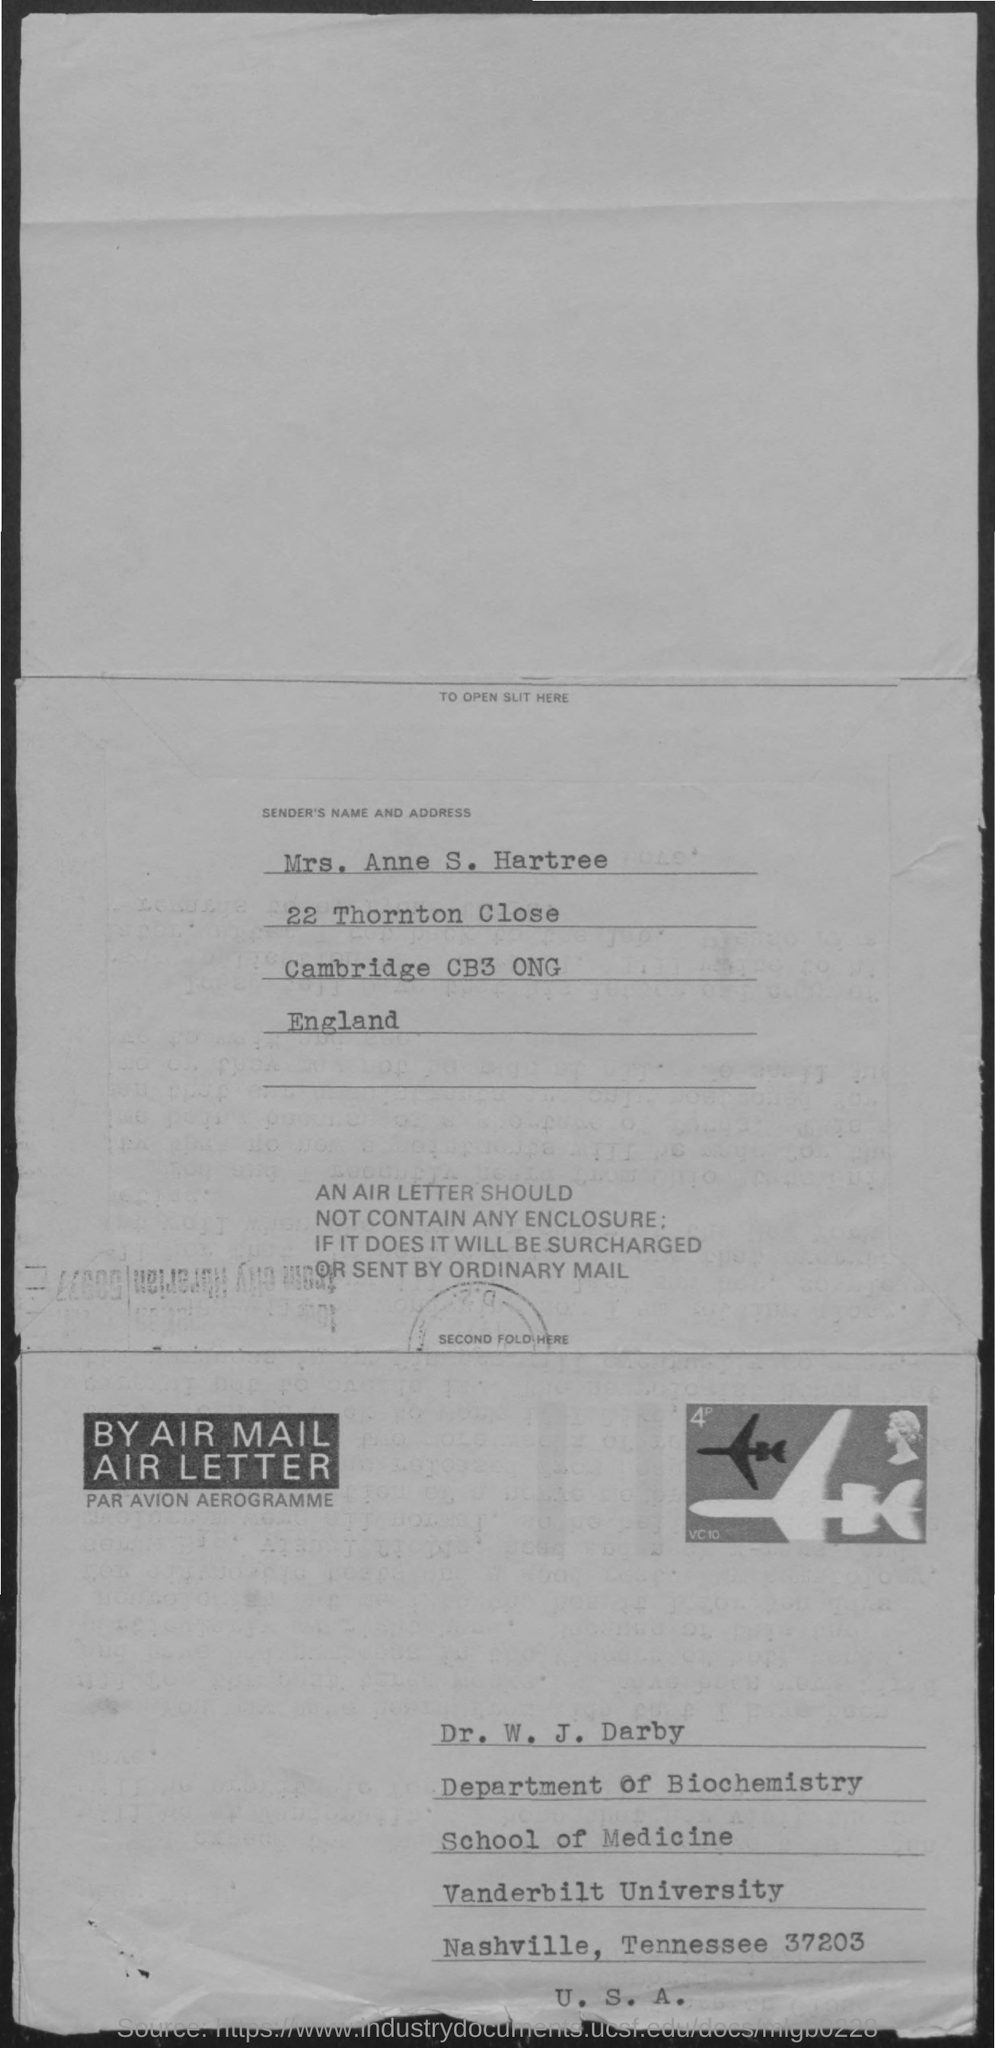What is the sender's name mentioned in the address?
Offer a terse response. Mrs. Anne S. Hartree. 